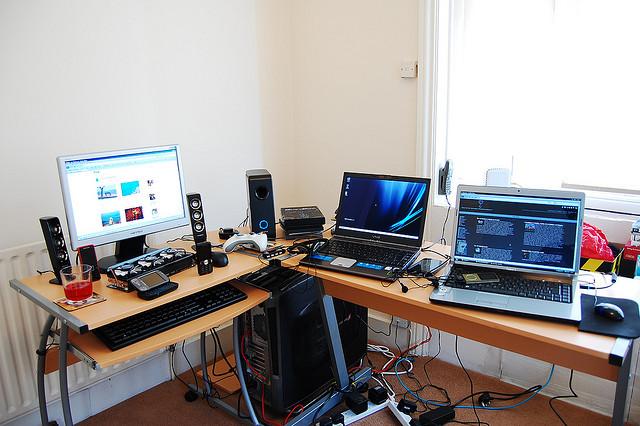How big is the center monitor?
Quick response, please. 17 inches. What color is the drink?
Be succinct. Red. What color are the laptop screens?
Write a very short answer. Blue. Are the contents of this desk expensive?
Write a very short answer. Yes. Is that a drum set near the windows?
Give a very brief answer. No. 